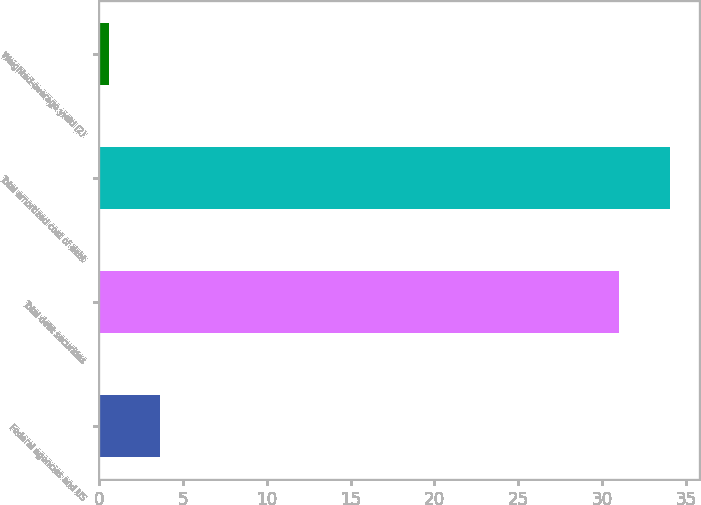Convert chart. <chart><loc_0><loc_0><loc_500><loc_500><bar_chart><fcel>Federal agencies and US<fcel>Total debt securities<fcel>Total amortized cost of debt<fcel>Weighted-average yield (2)<nl><fcel>3.67<fcel>31<fcel>34.04<fcel>0.63<nl></chart> 